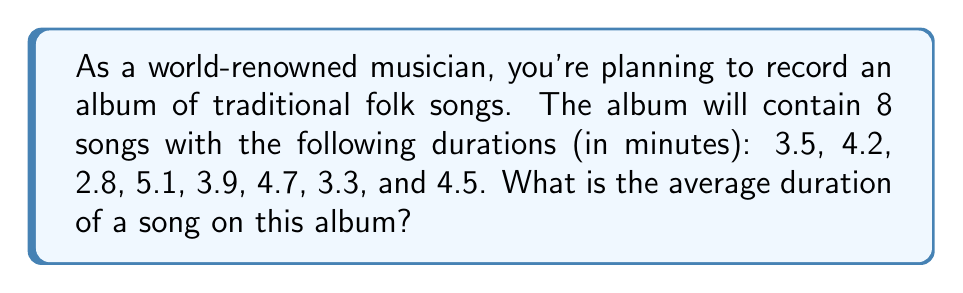Help me with this question. To find the average duration of songs in the album, we need to:

1. Sum up the durations of all songs
2. Divide the sum by the total number of songs

Let's follow these steps:

1. Sum of song durations:
   $$3.5 + 4.2 + 2.8 + 5.1 + 3.9 + 4.7 + 3.3 + 4.5 = 32$$

2. Number of songs: 8

3. Calculate the average:
   $$\text{Average} = \frac{\text{Sum of durations}}{\text{Number of songs}} = \frac{32}{8} = 4$$

Therefore, the average duration of a song on this album is 4 minutes.
Answer: $4$ minutes 